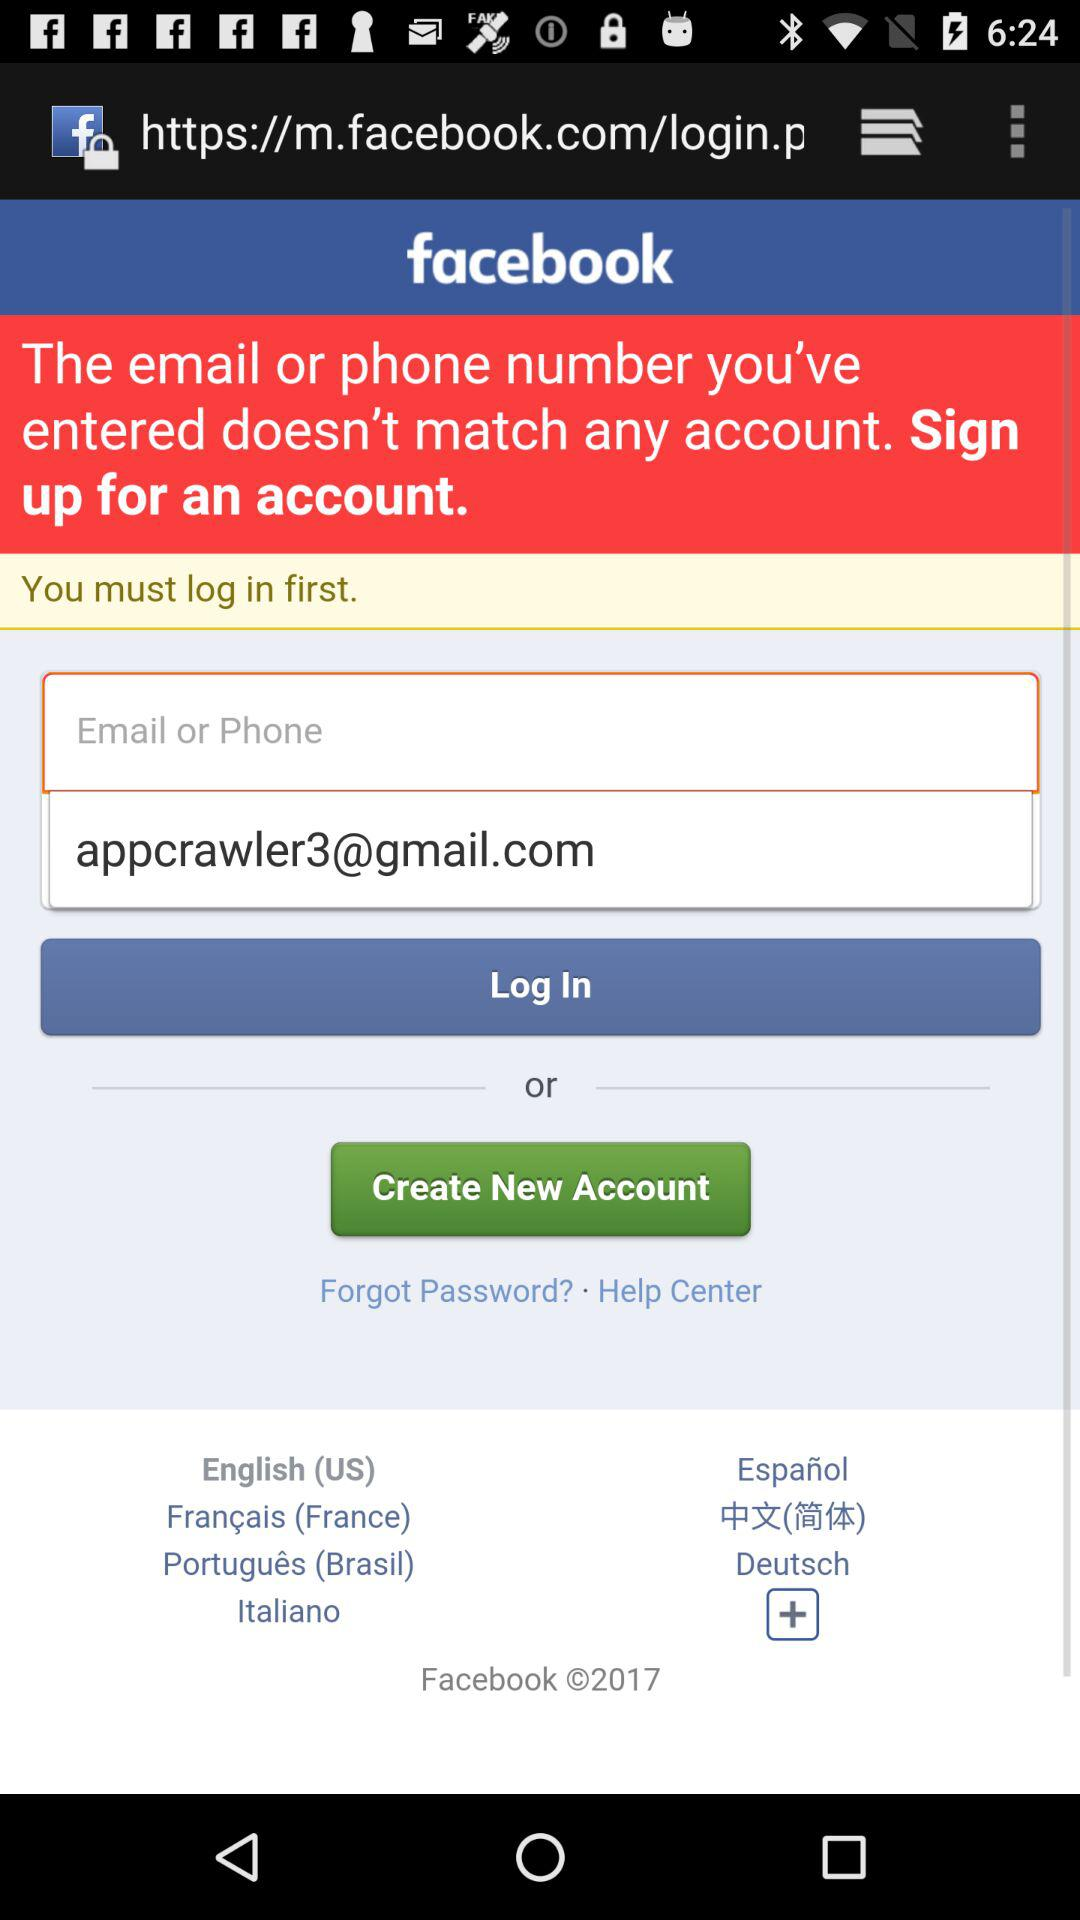What is the email address?
Answer the question using a single word or phrase. The email address is appcrawler3@gmail.com 